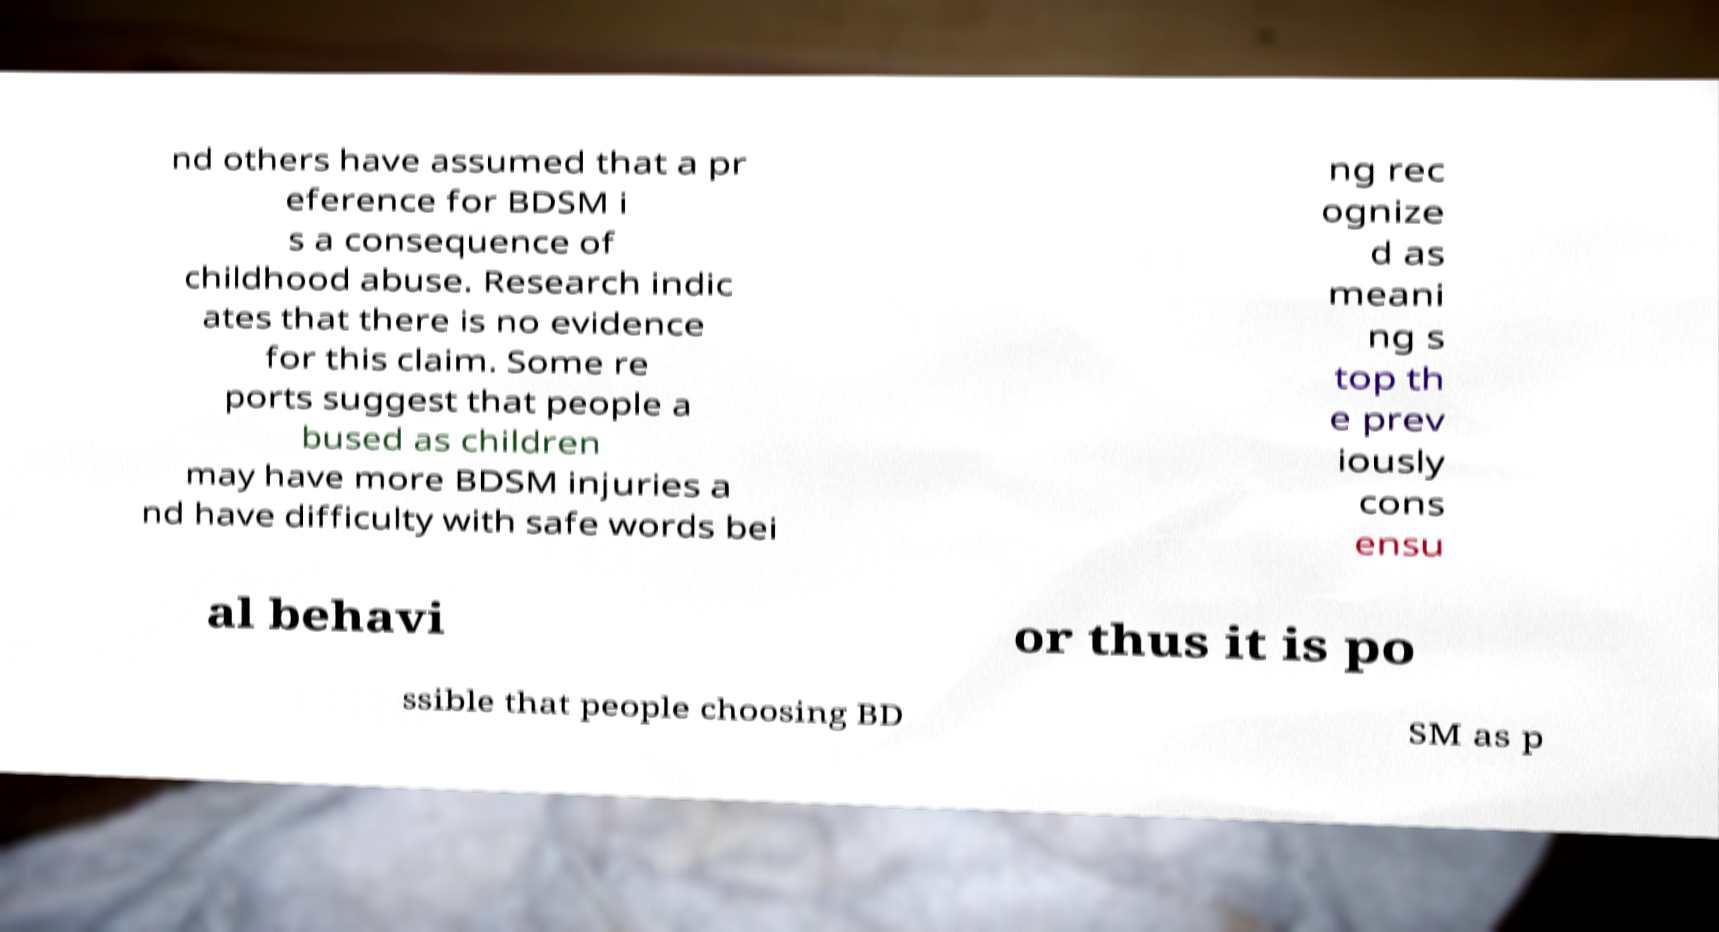I need the written content from this picture converted into text. Can you do that? nd others have assumed that a pr eference for BDSM i s a consequence of childhood abuse. Research indic ates that there is no evidence for this claim. Some re ports suggest that people a bused as children may have more BDSM injuries a nd have difficulty with safe words bei ng rec ognize d as meani ng s top th e prev iously cons ensu al behavi or thus it is po ssible that people choosing BD SM as p 